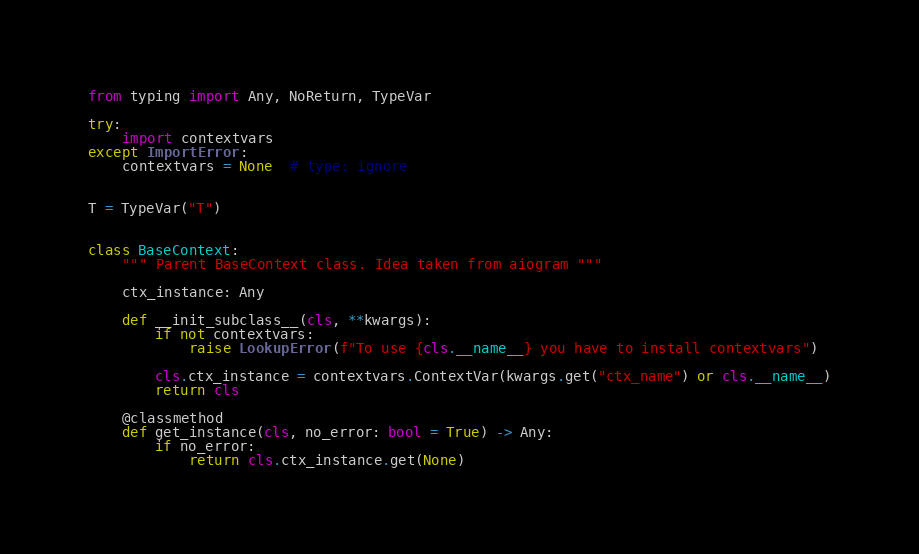Convert code to text. <code><loc_0><loc_0><loc_500><loc_500><_Python_>from typing import Any, NoReturn, TypeVar

try:
    import contextvars
except ImportError:
    contextvars = None  # type: ignore


T = TypeVar("T")


class BaseContext:
    """ Parent BaseContext class. Idea taken from aiogram """

    ctx_instance: Any

    def __init_subclass__(cls, **kwargs):
        if not contextvars:
            raise LookupError(f"To use {cls.__name__} you have to install contextvars")

        cls.ctx_instance = contextvars.ContextVar(kwargs.get("ctx_name") or cls.__name__)
        return cls

    @classmethod
    def get_instance(cls, no_error: bool = True) -> Any:
        if no_error:
            return cls.ctx_instance.get(None)</code> 